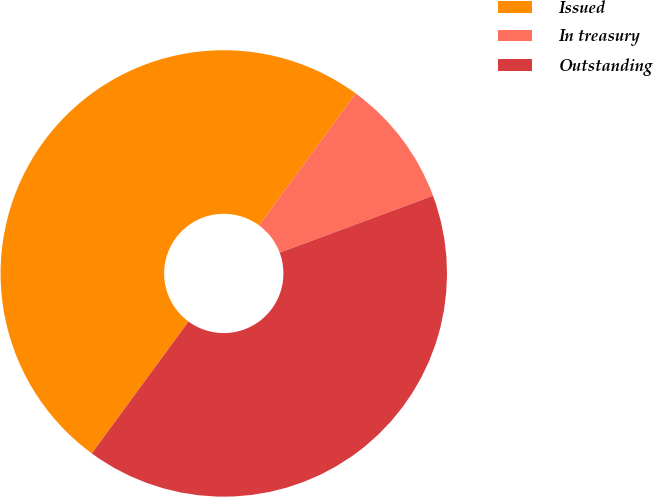Convert chart to OTSL. <chart><loc_0><loc_0><loc_500><loc_500><pie_chart><fcel>Issued<fcel>In treasury<fcel>Outstanding<nl><fcel>50.0%<fcel>9.27%<fcel>40.73%<nl></chart> 